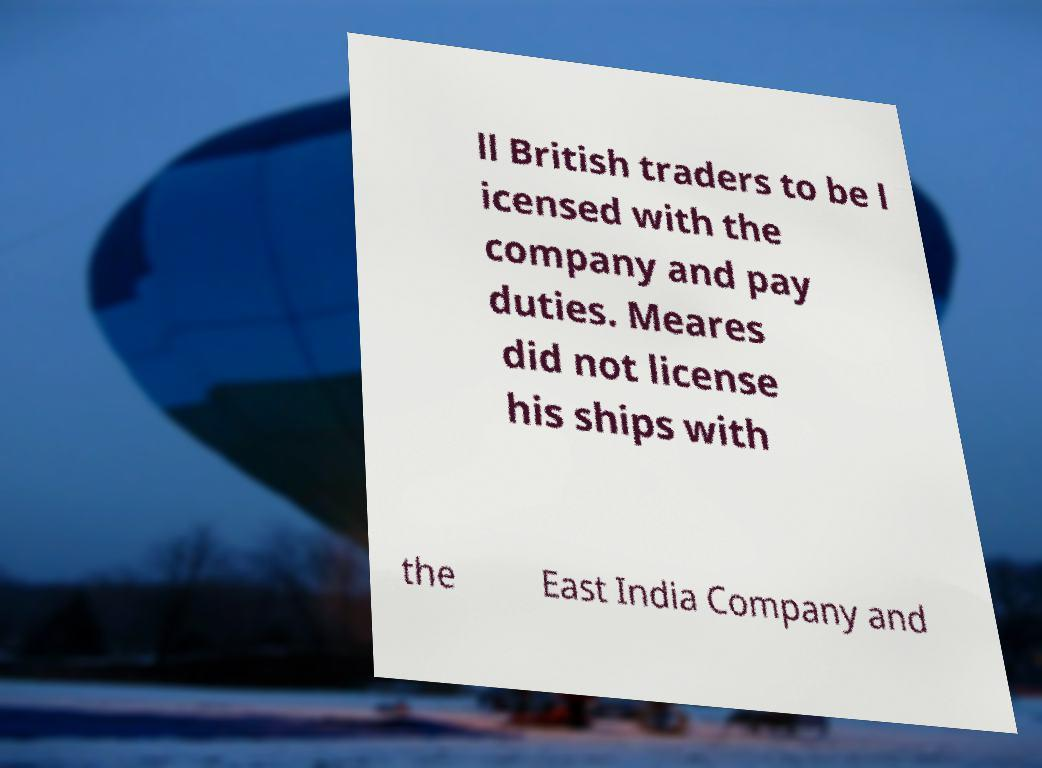For documentation purposes, I need the text within this image transcribed. Could you provide that? ll British traders to be l icensed with the company and pay duties. Meares did not license his ships with the East India Company and 